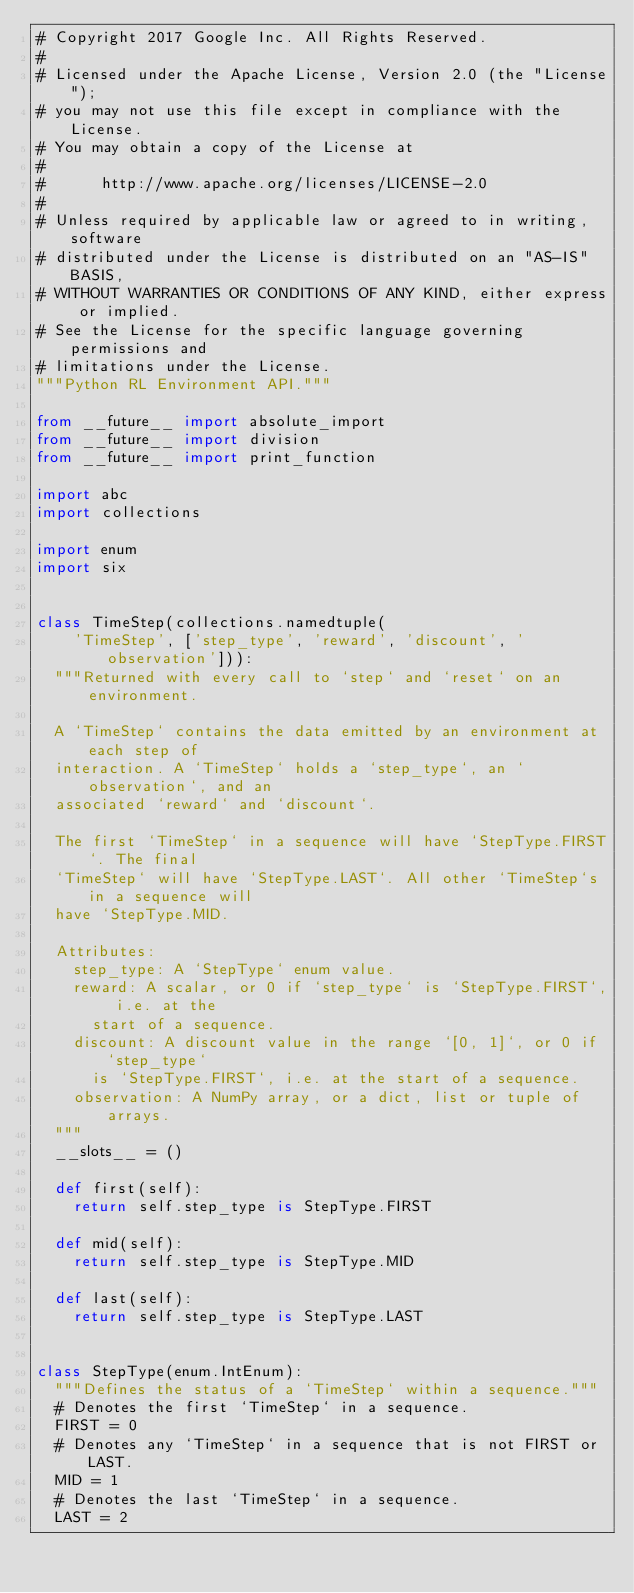<code> <loc_0><loc_0><loc_500><loc_500><_Python_># Copyright 2017 Google Inc. All Rights Reserved.
#
# Licensed under the Apache License, Version 2.0 (the "License");
# you may not use this file except in compliance with the License.
# You may obtain a copy of the License at
#
#      http://www.apache.org/licenses/LICENSE-2.0
#
# Unless required by applicable law or agreed to in writing, software
# distributed under the License is distributed on an "AS-IS" BASIS,
# WITHOUT WARRANTIES OR CONDITIONS OF ANY KIND, either express or implied.
# See the License for the specific language governing permissions and
# limitations under the License.
"""Python RL Environment API."""

from __future__ import absolute_import
from __future__ import division
from __future__ import print_function

import abc
import collections

import enum
import six


class TimeStep(collections.namedtuple(
    'TimeStep', ['step_type', 'reward', 'discount', 'observation'])):
  """Returned with every call to `step` and `reset` on an environment.

  A `TimeStep` contains the data emitted by an environment at each step of
  interaction. A `TimeStep` holds a `step_type`, an `observation`, and an
  associated `reward` and `discount`.

  The first `TimeStep` in a sequence will have `StepType.FIRST`. The final
  `TimeStep` will have `StepType.LAST`. All other `TimeStep`s in a sequence will
  have `StepType.MID.

  Attributes:
    step_type: A `StepType` enum value.
    reward: A scalar, or 0 if `step_type` is `StepType.FIRST`, i.e. at the
      start of a sequence.
    discount: A discount value in the range `[0, 1]`, or 0 if `step_type`
      is `StepType.FIRST`, i.e. at the start of a sequence.
    observation: A NumPy array, or a dict, list or tuple of arrays.
  """
  __slots__ = ()

  def first(self):
    return self.step_type is StepType.FIRST

  def mid(self):
    return self.step_type is StepType.MID

  def last(self):
    return self.step_type is StepType.LAST


class StepType(enum.IntEnum):
  """Defines the status of a `TimeStep` within a sequence."""
  # Denotes the first `TimeStep` in a sequence.
  FIRST = 0
  # Denotes any `TimeStep` in a sequence that is not FIRST or LAST.
  MID = 1
  # Denotes the last `TimeStep` in a sequence.
  LAST = 2

</code> 